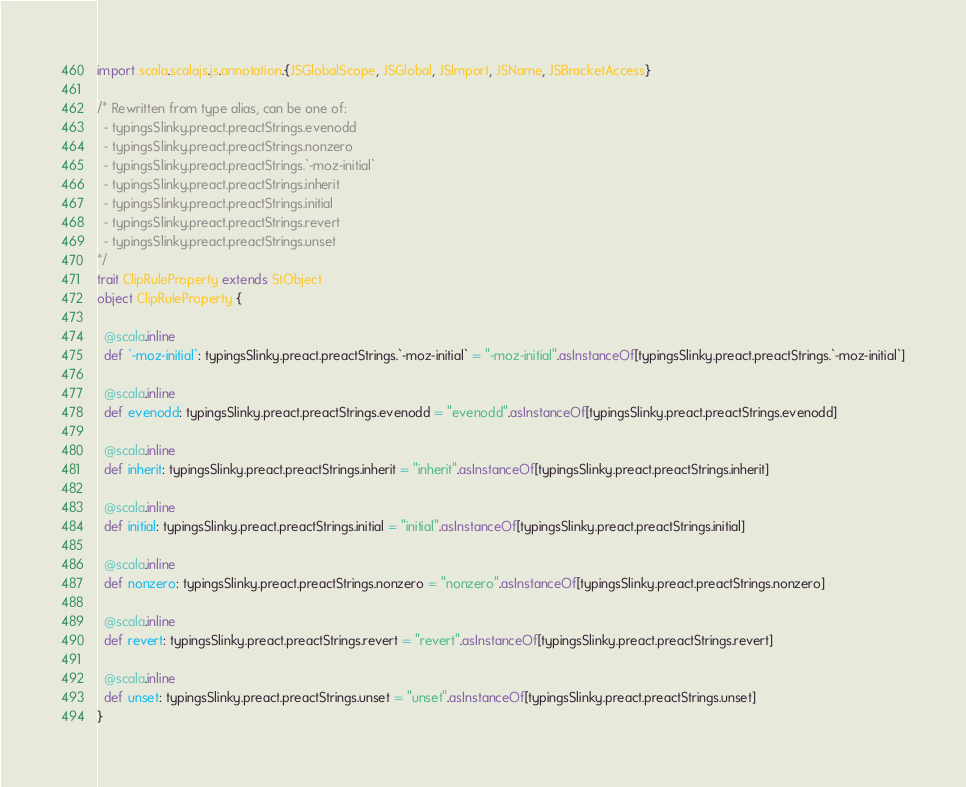<code> <loc_0><loc_0><loc_500><loc_500><_Scala_>import scala.scalajs.js.annotation.{JSGlobalScope, JSGlobal, JSImport, JSName, JSBracketAccess}

/* Rewritten from type alias, can be one of: 
  - typingsSlinky.preact.preactStrings.evenodd
  - typingsSlinky.preact.preactStrings.nonzero
  - typingsSlinky.preact.preactStrings.`-moz-initial`
  - typingsSlinky.preact.preactStrings.inherit
  - typingsSlinky.preact.preactStrings.initial
  - typingsSlinky.preact.preactStrings.revert
  - typingsSlinky.preact.preactStrings.unset
*/
trait ClipRuleProperty extends StObject
object ClipRuleProperty {
  
  @scala.inline
  def `-moz-initial`: typingsSlinky.preact.preactStrings.`-moz-initial` = "-moz-initial".asInstanceOf[typingsSlinky.preact.preactStrings.`-moz-initial`]
  
  @scala.inline
  def evenodd: typingsSlinky.preact.preactStrings.evenodd = "evenodd".asInstanceOf[typingsSlinky.preact.preactStrings.evenodd]
  
  @scala.inline
  def inherit: typingsSlinky.preact.preactStrings.inherit = "inherit".asInstanceOf[typingsSlinky.preact.preactStrings.inherit]
  
  @scala.inline
  def initial: typingsSlinky.preact.preactStrings.initial = "initial".asInstanceOf[typingsSlinky.preact.preactStrings.initial]
  
  @scala.inline
  def nonzero: typingsSlinky.preact.preactStrings.nonzero = "nonzero".asInstanceOf[typingsSlinky.preact.preactStrings.nonzero]
  
  @scala.inline
  def revert: typingsSlinky.preact.preactStrings.revert = "revert".asInstanceOf[typingsSlinky.preact.preactStrings.revert]
  
  @scala.inline
  def unset: typingsSlinky.preact.preactStrings.unset = "unset".asInstanceOf[typingsSlinky.preact.preactStrings.unset]
}
</code> 